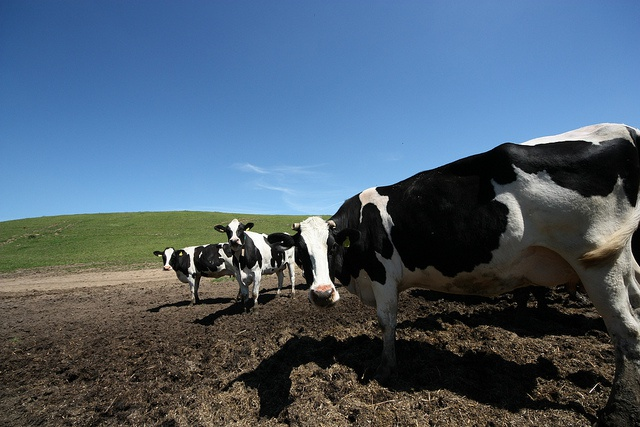Describe the objects in this image and their specific colors. I can see cow in blue, black, gray, darkgray, and lightgray tones, cow in blue, black, ivory, gray, and darkgray tones, and cow in blue, black, ivory, gray, and darkgray tones in this image. 